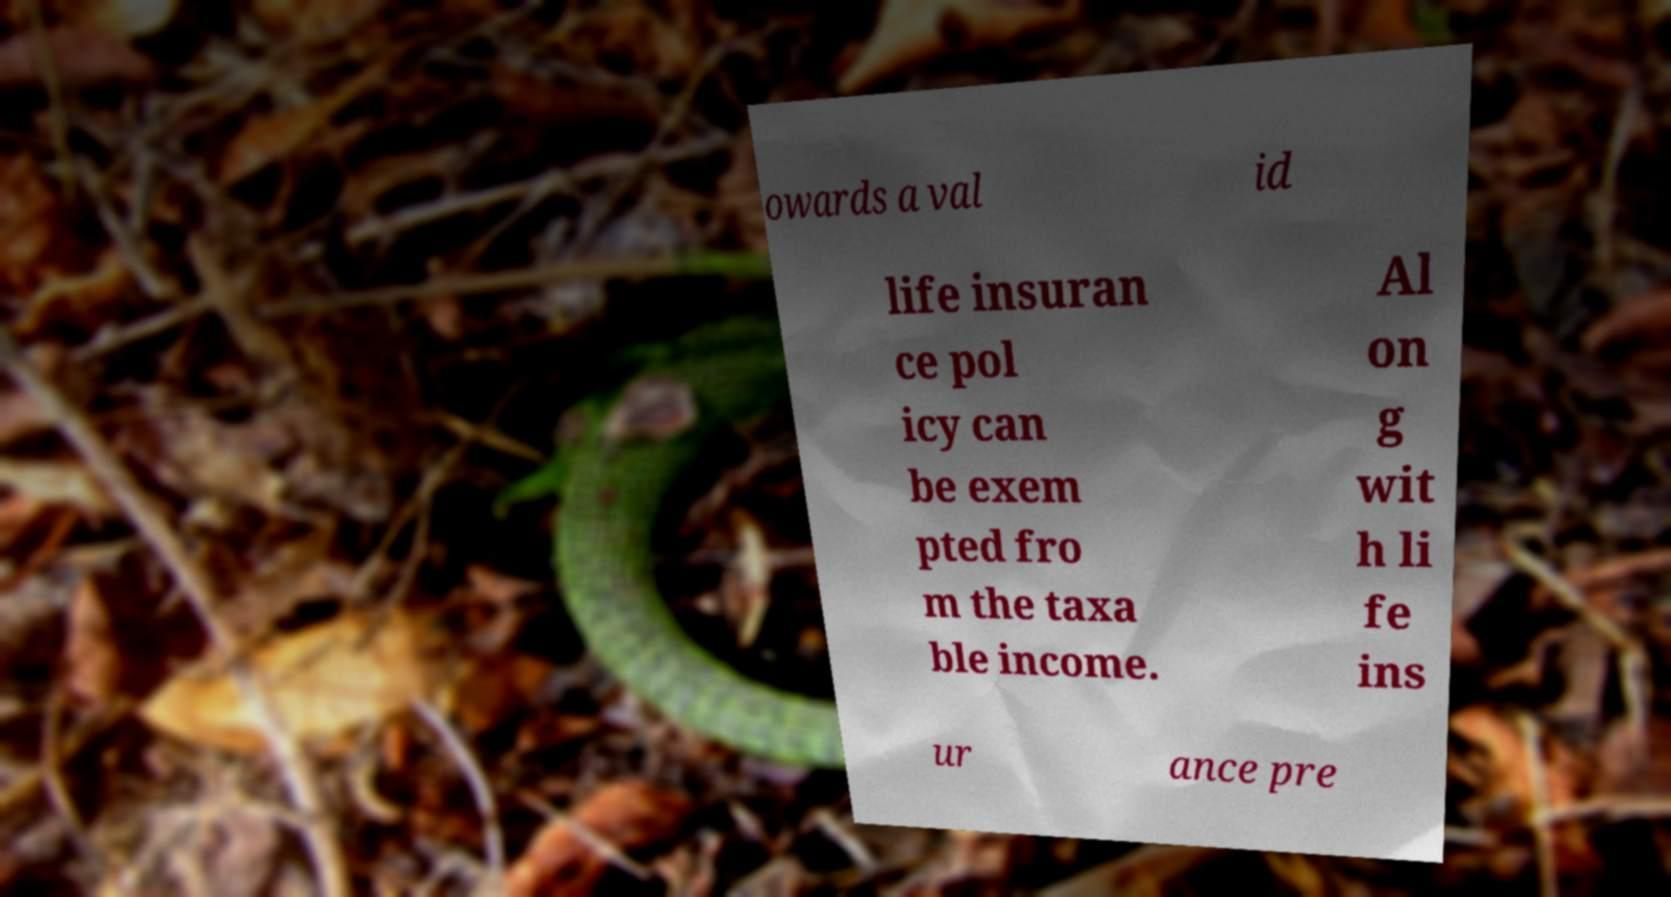What messages or text are displayed in this image? I need them in a readable, typed format. owards a val id life insuran ce pol icy can be exem pted fro m the taxa ble income. Al on g wit h li fe ins ur ance pre 